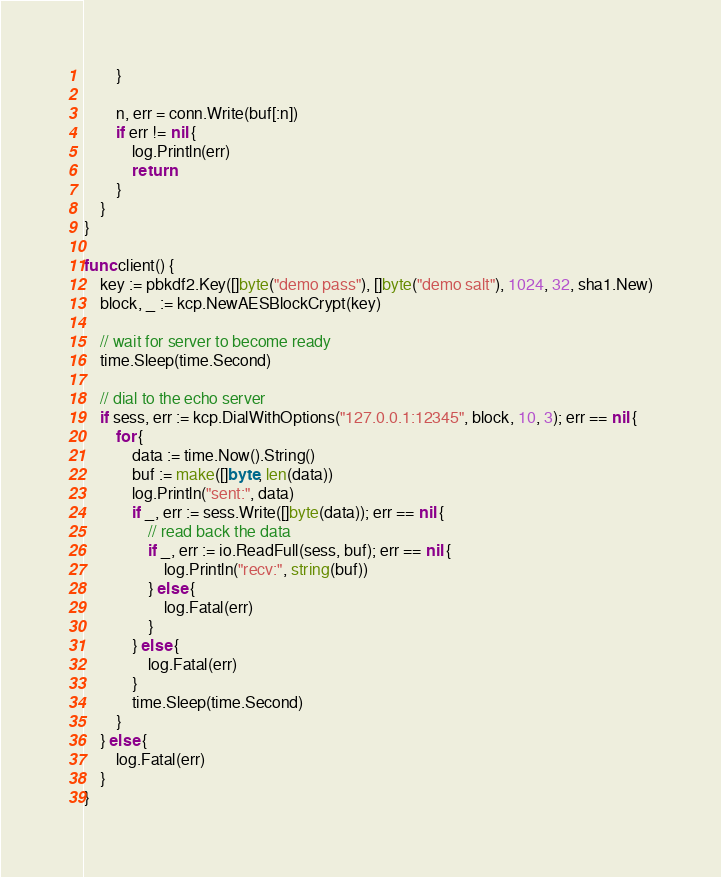Convert code to text. <code><loc_0><loc_0><loc_500><loc_500><_Go_>		}

		n, err = conn.Write(buf[:n])
		if err != nil {
			log.Println(err)
			return
		}
	}
}

func client() {
	key := pbkdf2.Key([]byte("demo pass"), []byte("demo salt"), 1024, 32, sha1.New)
	block, _ := kcp.NewAESBlockCrypt(key)

	// wait for server to become ready
	time.Sleep(time.Second)

	// dial to the echo server
	if sess, err := kcp.DialWithOptions("127.0.0.1:12345", block, 10, 3); err == nil {
		for {
			data := time.Now().String()
			buf := make([]byte, len(data))
			log.Println("sent:", data)
			if _, err := sess.Write([]byte(data)); err == nil {
				// read back the data
				if _, err := io.ReadFull(sess, buf); err == nil {
					log.Println("recv:", string(buf))
				} else {
					log.Fatal(err)
				}
			} else {
				log.Fatal(err)
			}
			time.Sleep(time.Second)
		}
	} else {
		log.Fatal(err)
	}
}
</code> 